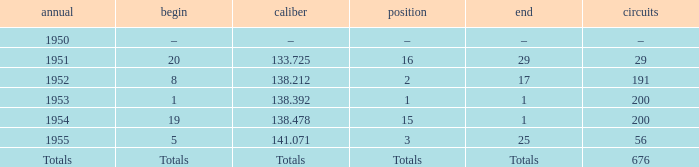What finish qualified at 141.071? 25.0. 